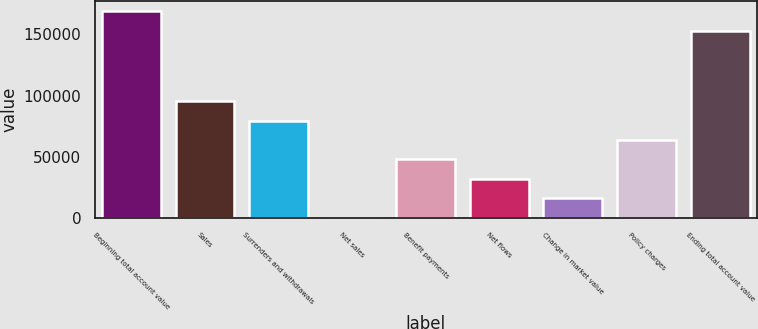<chart> <loc_0><loc_0><loc_500><loc_500><bar_chart><fcel>Beginning total account value<fcel>Sales<fcel>Surrenders and withdrawals<fcel>Net sales<fcel>Benefit payments<fcel>Net flows<fcel>Change in market value<fcel>Policy charges<fcel>Ending total account value<nl><fcel>168775<fcel>95344.4<fcel>79514.5<fcel>365<fcel>47854.7<fcel>32024.8<fcel>16194.9<fcel>63684.6<fcel>152945<nl></chart> 